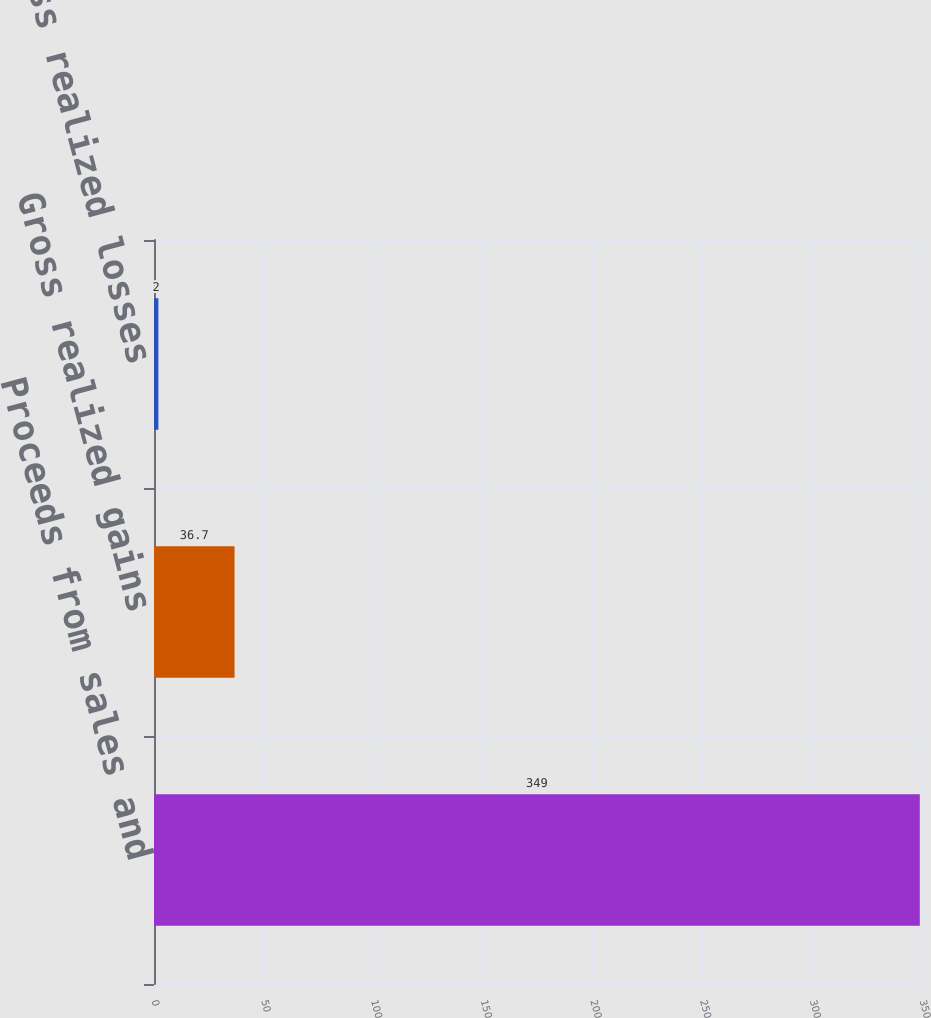<chart> <loc_0><loc_0><loc_500><loc_500><bar_chart><fcel>Proceeds from sales and<fcel>Gross realized gains<fcel>Gross realized losses<nl><fcel>349<fcel>36.7<fcel>2<nl></chart> 